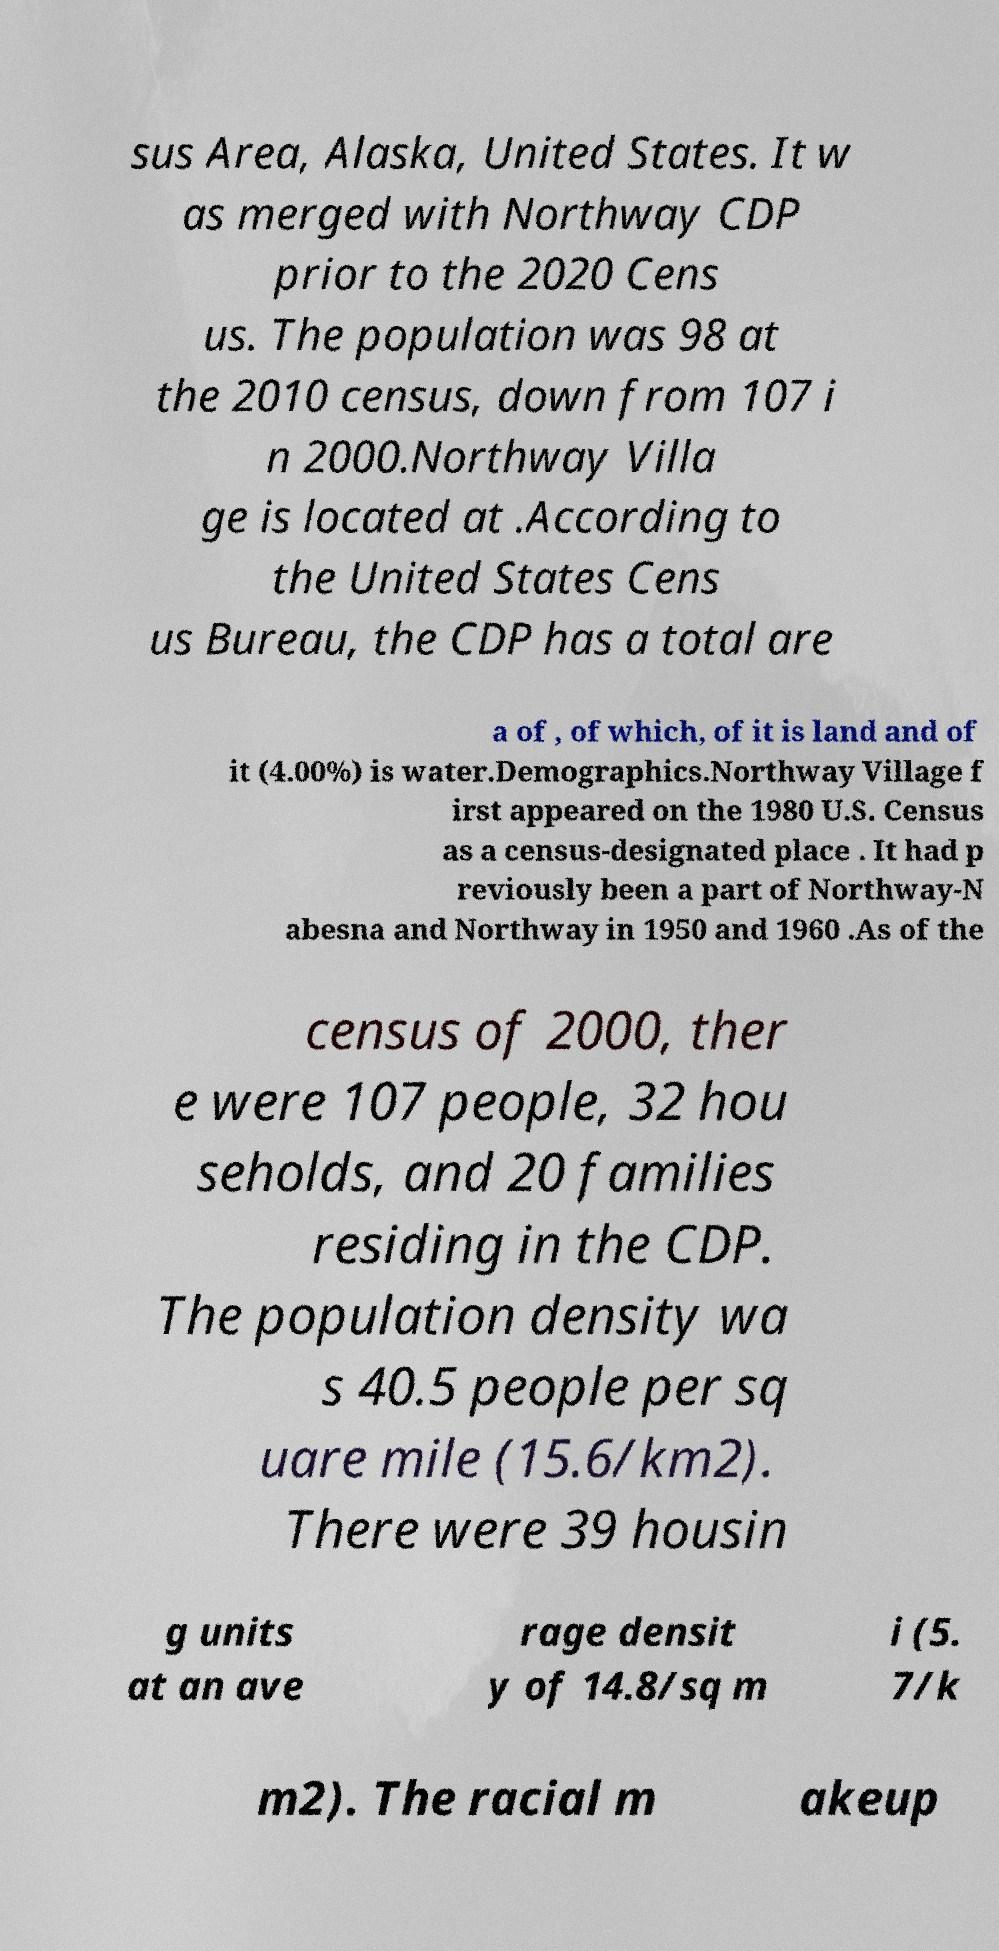Could you assist in decoding the text presented in this image and type it out clearly? sus Area, Alaska, United States. It w as merged with Northway CDP prior to the 2020 Cens us. The population was 98 at the 2010 census, down from 107 i n 2000.Northway Villa ge is located at .According to the United States Cens us Bureau, the CDP has a total are a of , of which, of it is land and of it (4.00%) is water.Demographics.Northway Village f irst appeared on the 1980 U.S. Census as a census-designated place . It had p reviously been a part of Northway-N abesna and Northway in 1950 and 1960 .As of the census of 2000, ther e were 107 people, 32 hou seholds, and 20 families residing in the CDP. The population density wa s 40.5 people per sq uare mile (15.6/km2). There were 39 housin g units at an ave rage densit y of 14.8/sq m i (5. 7/k m2). The racial m akeup 